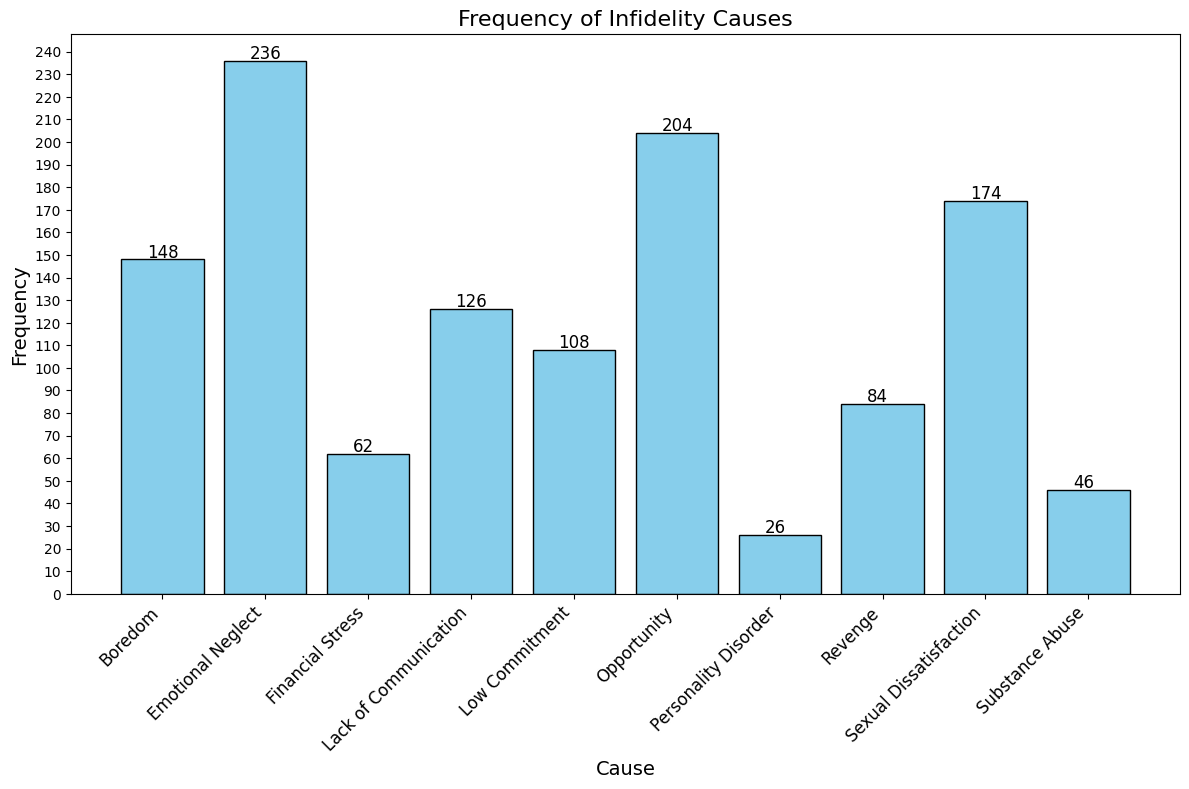Which cause of infidelity has the highest frequency? Looking at the highest bar in the histogram, which corresponds to Emotional Neglect with a frequency of 236
Answer: Emotional Neglect Which cause of infidelity has the lowest frequency? Looking at the shortest bar in the histogram, which corresponds to Personality Disorder with a frequency of 26
Answer: Personality Disorder How many more instances of Emotional Neglect are there compared to Financial Stress? Subtract the frequency of Financial Stress (62) from the frequency of Emotional Neglect (236), i.e., 236 - 62 = 174
Answer: 174 What is the total frequency of Sexual Dissatisfaction and Opportunity combined? Add the frequencies of Sexual Dissatisfaction (174) and Opportunity (204), i.e., 174 + 204 = 378
Answer: 378 How does the frequency of Boredom compare to that of Revenge? Compare the heights of the bars for Boredom (148) and Revenge (84). Boredom's bar is taller, indicating a higher frequency
Answer: Boredom is higher Which infidelity cause has a frequency closest to 100? Looking for the bar whose height visually approximates 100, which is Low Commitment with a frequency of 108
Answer: Low Commitment If you sum the frequencies of the two least frequent causes, what is the result? Add the frequencies of Personality Disorder (26) and Substance Abuse (46), i.e., 26 + 46 = 72
Answer: 72 Which is more frequent: Lack of Communication or Low Commitment? Compare the heights of the bars for Lack of Communication (126) and Low Commitment (108). Lack of Communication is higher
Answer: Lack of Communication How does the frequency of Sexual Dissatisfaction compare to Emotional Neglect in terms of percentage difference? Calculate the percentage difference where Sexual Dissatisfaction is 174 and Emotional Neglect is 236. The percentage difference is ((236 - 174) / 236) * 100 ≈ 26.27%
Answer: 26.27% Which cause saw exactly twice the frequency of the least frequent cause? The least frequent cause is Personality Disorder with a frequency of 26. Twice this is 52. Substance Abuse has a frequency of 52, which matches this
Answer: Substance Abuse 